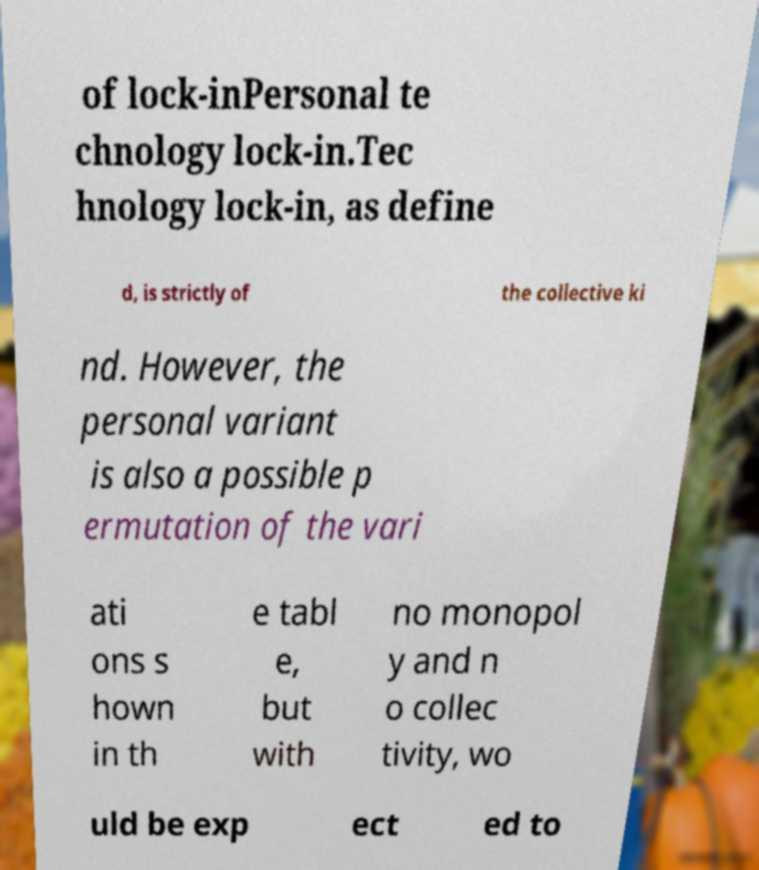There's text embedded in this image that I need extracted. Can you transcribe it verbatim? of lock-inPersonal te chnology lock-in.Tec hnology lock-in, as define d, is strictly of the collective ki nd. However, the personal variant is also a possible p ermutation of the vari ati ons s hown in th e tabl e, but with no monopol y and n o collec tivity, wo uld be exp ect ed to 